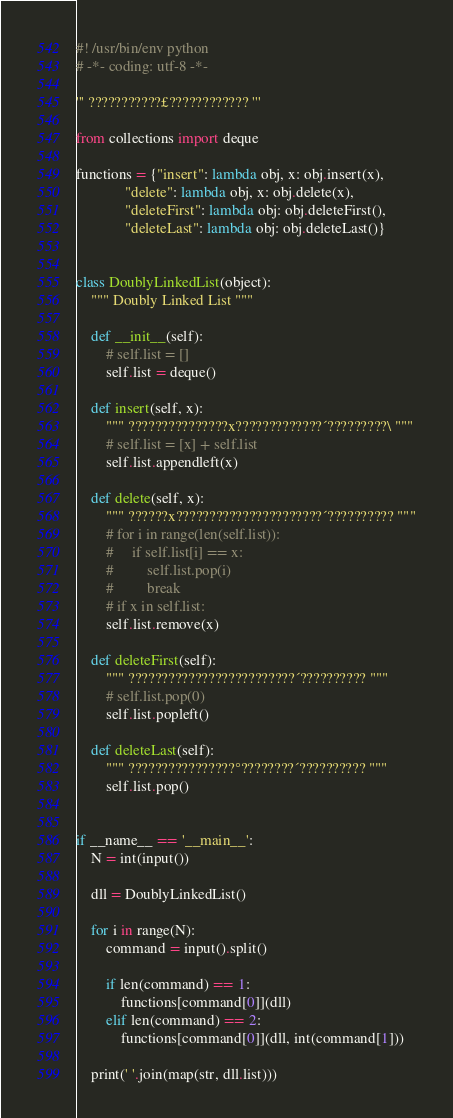Convert code to text. <code><loc_0><loc_0><loc_500><loc_500><_Python_>#! /usr/bin/env python
# -*- coding: utf-8 -*-

''' ???????????£???????????? '''

from collections import deque

functions = {"insert": lambda obj, x: obj.insert(x),
             "delete": lambda obj, x: obj.delete(x),
             "deleteFirst": lambda obj: obj.deleteFirst(),
             "deleteLast": lambda obj: obj.deleteLast()}


class DoublyLinkedList(object):
    """ Doubly Linked List """

    def __init__(self):
        # self.list = []
        self.list = deque()

    def insert(self, x):
        """ ???????????????x?????????????´?????????\ """
        # self.list = [x] + self.list
        self.list.appendleft(x)

    def delete(self, x):
        """ ??????x??????????????????????´?????????? """
        # for i in range(len(self.list)):
        #     if self.list[i] == x:
        #         self.list.pop(i)
        #         break
        # if x in self.list:
        self.list.remove(x)

    def deleteFirst(self):
        """ ?????????????????????????´?????????? """
        # self.list.pop(0)
        self.list.popleft()

    def deleteLast(self):
        """ ????????????????°????????´?????????? """
        self.list.pop()


if __name__ == '__main__':
    N = int(input())

    dll = DoublyLinkedList()

    for i in range(N):
        command = input().split()

        if len(command) == 1:
            functions[command[0]](dll)
        elif len(command) == 2:
            functions[command[0]](dll, int(command[1]))

    print(' '.join(map(str, dll.list)))</code> 